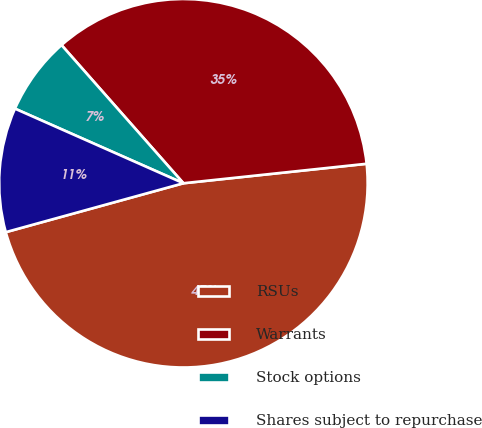Convert chart to OTSL. <chart><loc_0><loc_0><loc_500><loc_500><pie_chart><fcel>RSUs<fcel>Warrants<fcel>Stock options<fcel>Shares subject to repurchase<nl><fcel>47.41%<fcel>34.82%<fcel>6.86%<fcel>10.91%<nl></chart> 